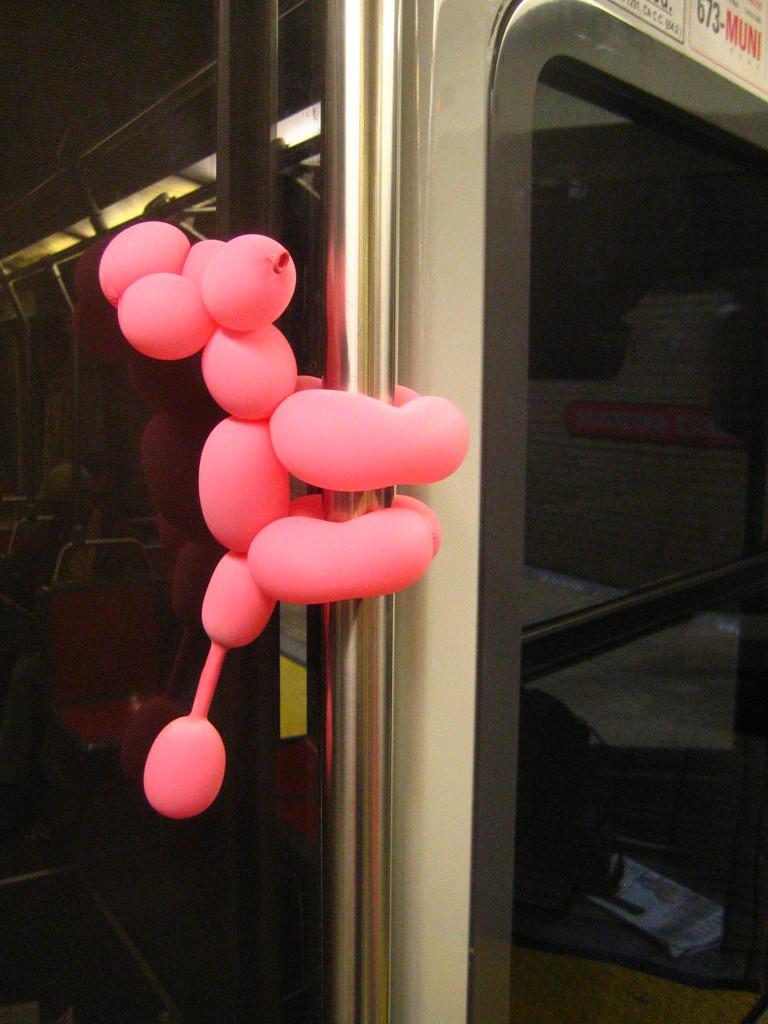What is the main subject of the image? The main subject of the image is a vehicle. Can you describe the person inside the vehicle? There is a woman seated in the vehicle. What additional decorative element can be seen in the image? Balloons are present on a rod in the image. What type of ice can be seen melting inside the vehicle? There is no ice present in the image, let alone melting ice. Can you see any steam coming from the vehicle in the image? There is no steam visible in the image. 